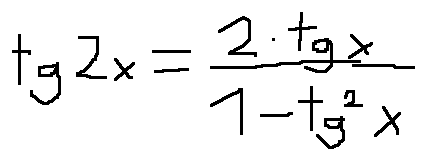Convert formula to latex. <formula><loc_0><loc_0><loc_500><loc_500>t g 2 x = \frac { 2 \cdot t g x } { 1 - t g ^ { 2 } x }</formula> 